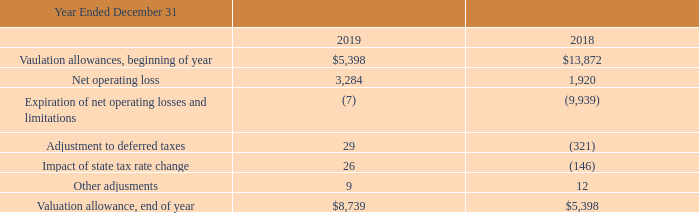The following table summarizes the change in the valuation allowance (in thousands):
As of December 31, 2019, net operating loss (NOL) carryforwards for U.S. federal tax purposes totaled $31.4 million. Effective with the 2017 Tax Act in December 2017, NOLs generated after December 31, 2017, do not expire. Federal NOLs of $9.9 million expire at various dates from 2020 through 2037 and federal NOLs of $21.5 million do not expire. NOL carryforwards for state tax purposes totaled $40.6 million at December 31, 2019 and expire at various dates from 2020 through 2039.
What are the respective valuation allowances at the beginning of the year in 2018 and 2019?
Answer scale should be: thousand. $13,872, $5,398. What are the respective net operating loss in 2018 and 2019?
Answer scale should be: thousand. 1,920, 3,284. What are the respective valuation allowances at the end of the year in 2018 and 2019?
Answer scale should be: thousand. $5,398, $8,739. What is the change in valuation allowance in 2019?
Answer scale should be: thousand. 8,739 - 5,398 
Answer: 3341. What is the change in valuation allowance in 2018?
Answer scale should be: thousand. 5,398 - 13,872 
Answer: -8474. What is the change in net operating loss between 2018 and 2019?
Answer scale should be: thousand. 3,284 - 1,920 
Answer: 1364. 